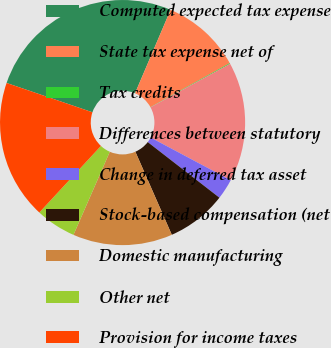<chart> <loc_0><loc_0><loc_500><loc_500><pie_chart><fcel>Computed expected tax expense<fcel>State tax expense net of<fcel>Tax credits<fcel>Differences between statutory<fcel>Change in deferred tax asset<fcel>Stock-based compensation (net<fcel>Domestic manufacturing<fcel>Other net<fcel>Provision for income taxes<nl><fcel>26.17%<fcel>10.53%<fcel>0.1%<fcel>15.75%<fcel>2.71%<fcel>7.92%<fcel>13.14%<fcel>5.32%<fcel>18.35%<nl></chart> 